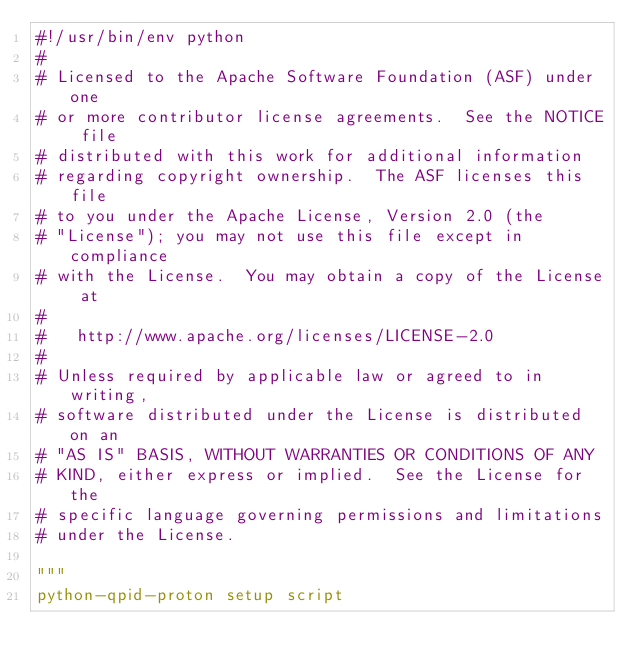<code> <loc_0><loc_0><loc_500><loc_500><_Python_>#!/usr/bin/env python
#
# Licensed to the Apache Software Foundation (ASF) under one
# or more contributor license agreements.  See the NOTICE file
# distributed with this work for additional information
# regarding copyright ownership.  The ASF licenses this file
# to you under the Apache License, Version 2.0 (the
# "License"); you may not use this file except in compliance
# with the License.  You may obtain a copy of the License at
#
#   http://www.apache.org/licenses/LICENSE-2.0
#
# Unless required by applicable law or agreed to in writing,
# software distributed under the License is distributed on an
# "AS IS" BASIS, WITHOUT WARRANTIES OR CONDITIONS OF ANY
# KIND, either express or implied.  See the License for the
# specific language governing permissions and limitations
# under the License.

"""
python-qpid-proton setup script
</code> 